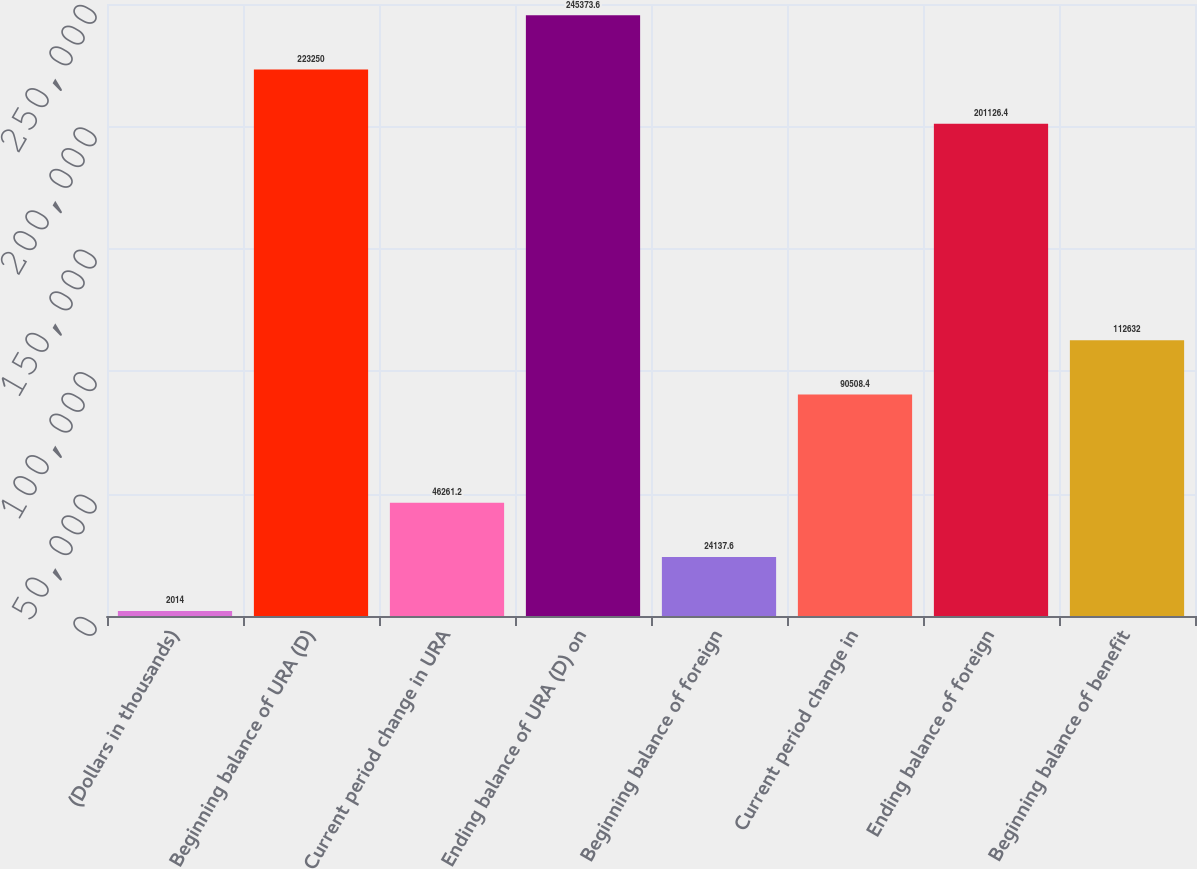Convert chart to OTSL. <chart><loc_0><loc_0><loc_500><loc_500><bar_chart><fcel>(Dollars in thousands)<fcel>Beginning balance of URA (D)<fcel>Current period change in URA<fcel>Ending balance of URA (D) on<fcel>Beginning balance of foreign<fcel>Current period change in<fcel>Ending balance of foreign<fcel>Beginning balance of benefit<nl><fcel>2014<fcel>223250<fcel>46261.2<fcel>245374<fcel>24137.6<fcel>90508.4<fcel>201126<fcel>112632<nl></chart> 